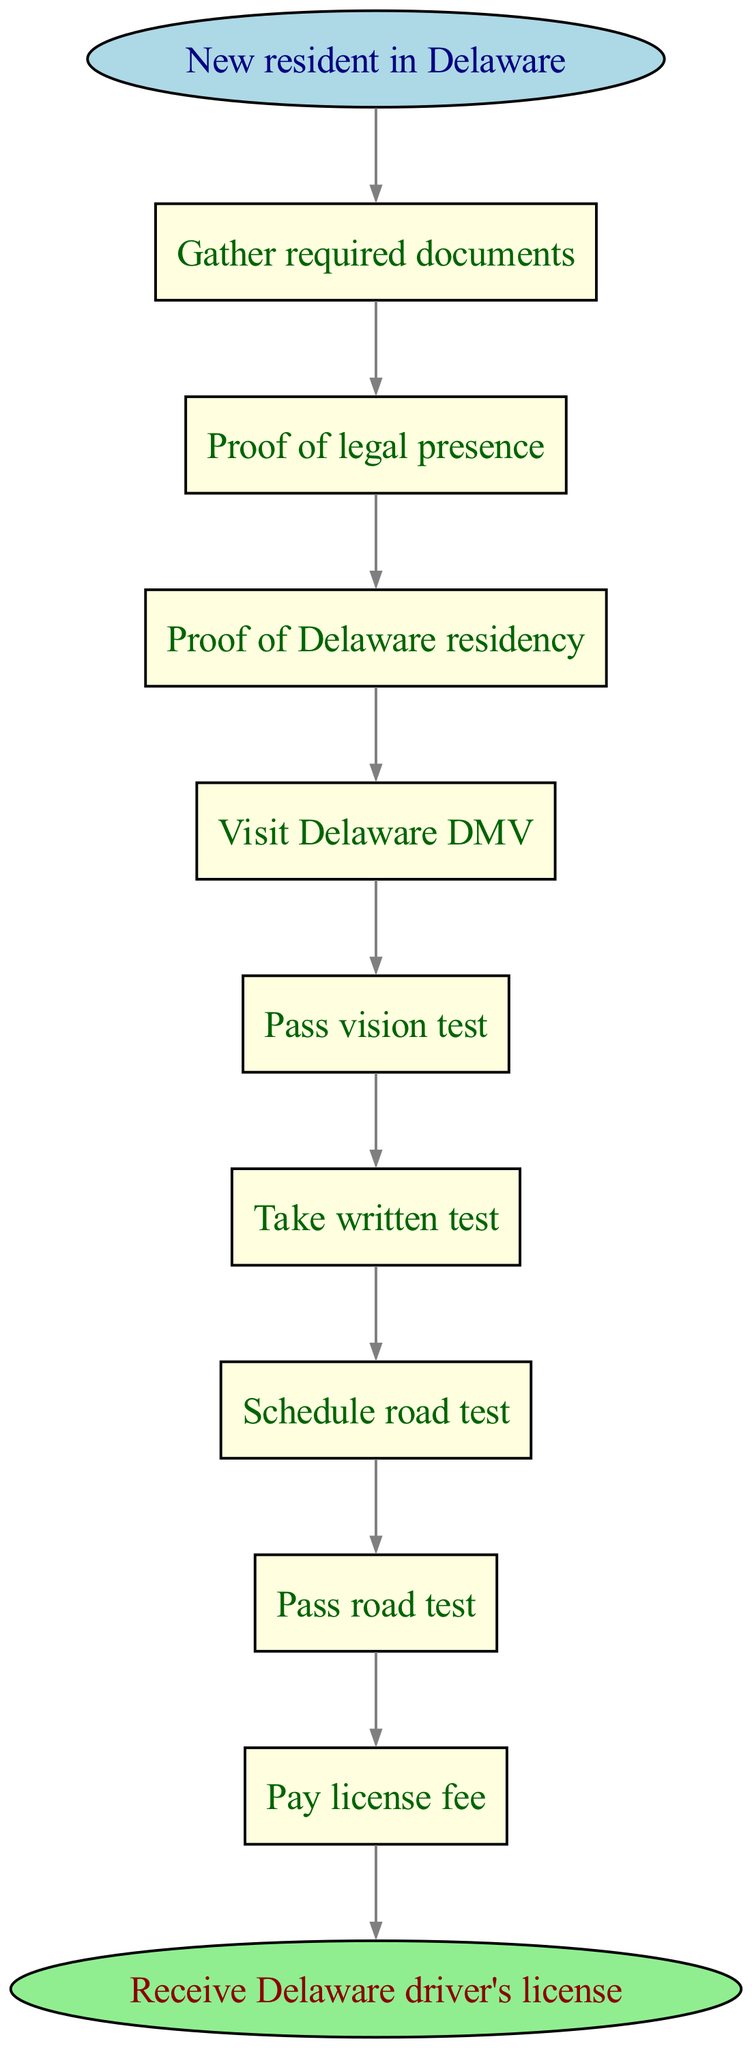What is the starting point of the process? The starting point of the process is clearly defined as "New resident in Delaware." This is indicated at the top of the diagram, representing the initial step in obtaining a driver's license.
Answer: New resident in Delaware How many total nodes are in the diagram? To determine the total nodes, we count the start node, the 8 process nodes (from gathering documents to paying the license fee), and the end node. Therefore, there are a total of 10 nodes in the diagram.
Answer: 10 What is the first action a new resident must take? The first action is to "Gather required documents." This is the text associated with the node directly following the starting point in the flowchart.
Answer: Gather required documents What follows after passing the vision test? After passing the vision test, the next action is "Take written test." This is a sequential step that occurs immediately after the vision test in the process flow.
Answer: Take written test What is the final step in obtaining the Delaware driver's license? The final step is "Receive Delaware driver's license." This represents the conclusion of the process, showing what is received after all previous actions have been completed successfully.
Answer: Receive Delaware driver's license What must be done before scheduling the road test? Before scheduling the road test, you must "Take written test." This is shown in the sequence leading up to the road test within the diagram.
Answer: Take written test What document is needed to prove Delaware residency? The document needed to prove Delaware residency is indicated in the flowchart as "Proof of Delaware residency." This shows the requirement explicitly before visiting the DMV.
Answer: Proof of Delaware residency How many tests must be passed before getting the license? The diagram illustrates that two tests must be passed: the vision test and the road test. These are critical steps leading to the final acquisition of the driver's license.
Answer: 2 